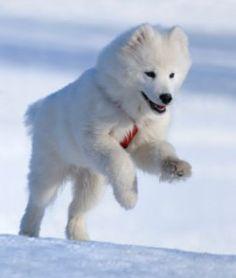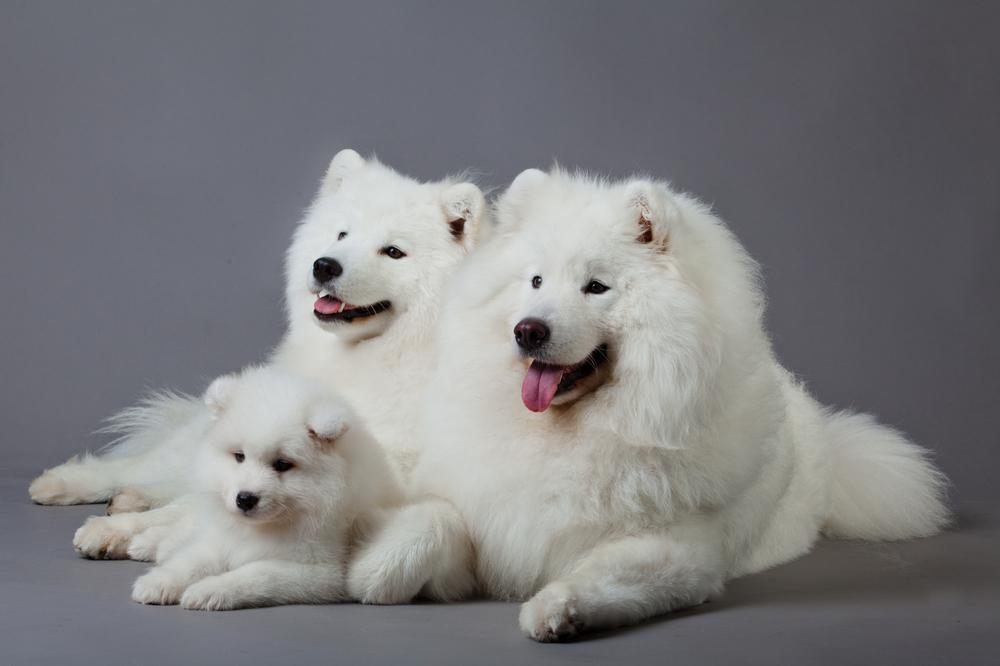The first image is the image on the left, the second image is the image on the right. For the images shown, is this caption "There are at least two dogs in the image on the right." true? Answer yes or no. Yes. The first image is the image on the left, the second image is the image on the right. Given the left and right images, does the statement "A white dog is outside in the snow." hold true? Answer yes or no. Yes. 